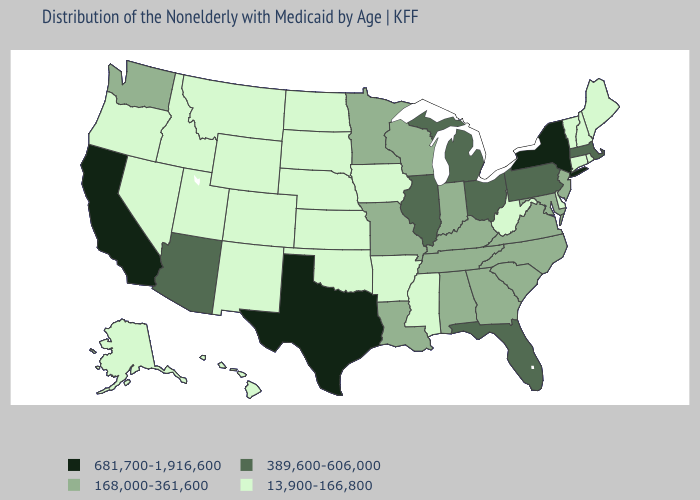Among the states that border Alabama , which have the lowest value?
Short answer required. Mississippi. Does Delaware have the highest value in the South?
Quick response, please. No. What is the value of Colorado?
Give a very brief answer. 13,900-166,800. Does Arizona have the lowest value in the USA?
Quick response, please. No. Name the states that have a value in the range 168,000-361,600?
Answer briefly. Alabama, Georgia, Indiana, Kentucky, Louisiana, Maryland, Minnesota, Missouri, New Jersey, North Carolina, South Carolina, Tennessee, Virginia, Washington, Wisconsin. What is the highest value in the USA?
Answer briefly. 681,700-1,916,600. What is the lowest value in the USA?
Keep it brief. 13,900-166,800. Which states have the highest value in the USA?
Write a very short answer. California, New York, Texas. Among the states that border Arizona , which have the highest value?
Quick response, please. California. What is the lowest value in states that border Oregon?
Keep it brief. 13,900-166,800. What is the highest value in the West ?
Be succinct. 681,700-1,916,600. What is the value of South Dakota?
Write a very short answer. 13,900-166,800. What is the highest value in the South ?
Short answer required. 681,700-1,916,600. How many symbols are there in the legend?
Quick response, please. 4. Does the first symbol in the legend represent the smallest category?
Write a very short answer. No. 